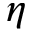Convert formula to latex. <formula><loc_0><loc_0><loc_500><loc_500>\eta</formula> 